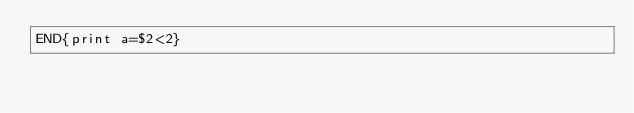Convert code to text. <code><loc_0><loc_0><loc_500><loc_500><_Awk_>END{print a=$2<2}</code> 